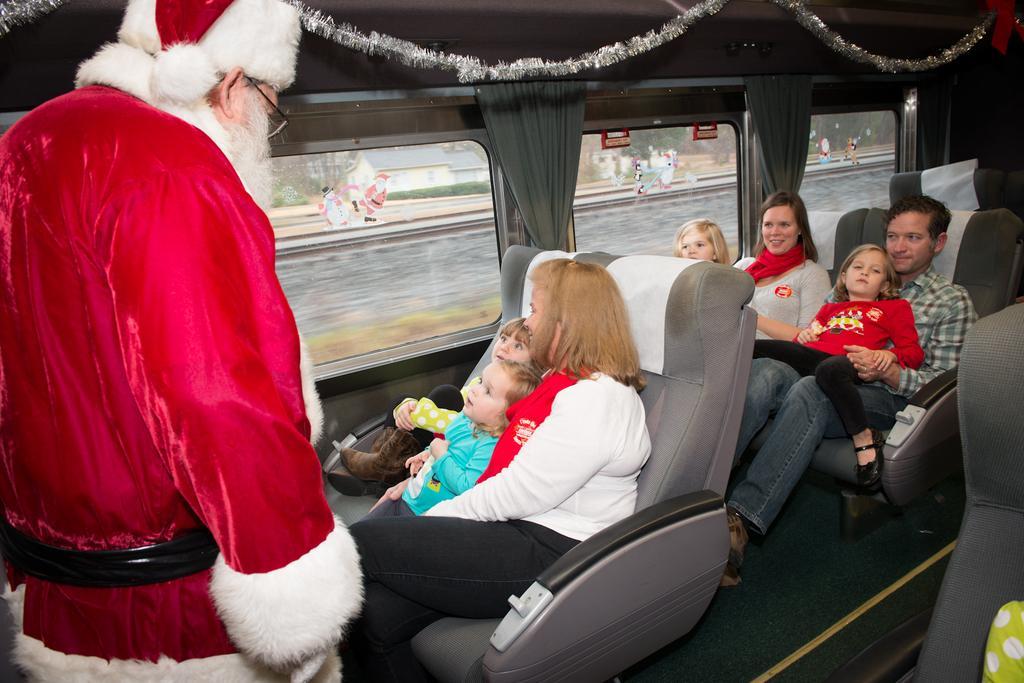In one or two sentences, can you explain what this image depicts? This is the picture of a vehicle. In this image there are group of people sitting and there is a person standing. At the back there are windows and there are curtains. At the top there is a decoration. There are stickers of a Santa claus on the window and behind the windows there are buildings and trees and there is a railway track. 